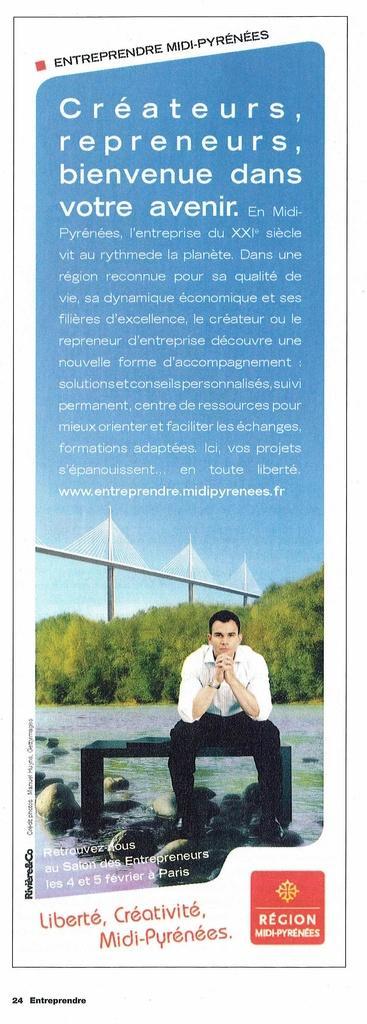Can you describe this image briefly? In this image, we can see a poster with some images and text. 